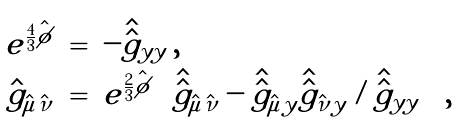<formula> <loc_0><loc_0><loc_500><loc_500>\begin{array} { r c l } { { e ^ { \frac { 4 } { 3 } \hat { \phi } } } } & { = } & { { - \hat { \hat { g } } _ { y y } \, , } } \\ { { \hat { g } _ { \hat { \mu } \hat { \nu } } } } & { = } & { { e ^ { \frac { 2 } { 3 } \hat { \phi } } \left [ \hat { \hat { g } } _ { \hat { \mu } \hat { \nu } } - \hat { \hat { g } } _ { \hat { \mu } y } \hat { \hat { g } } _ { \hat { \nu } y } / \hat { \hat { g } } _ { y y } \right ] \, , } } \end{array}</formula> 